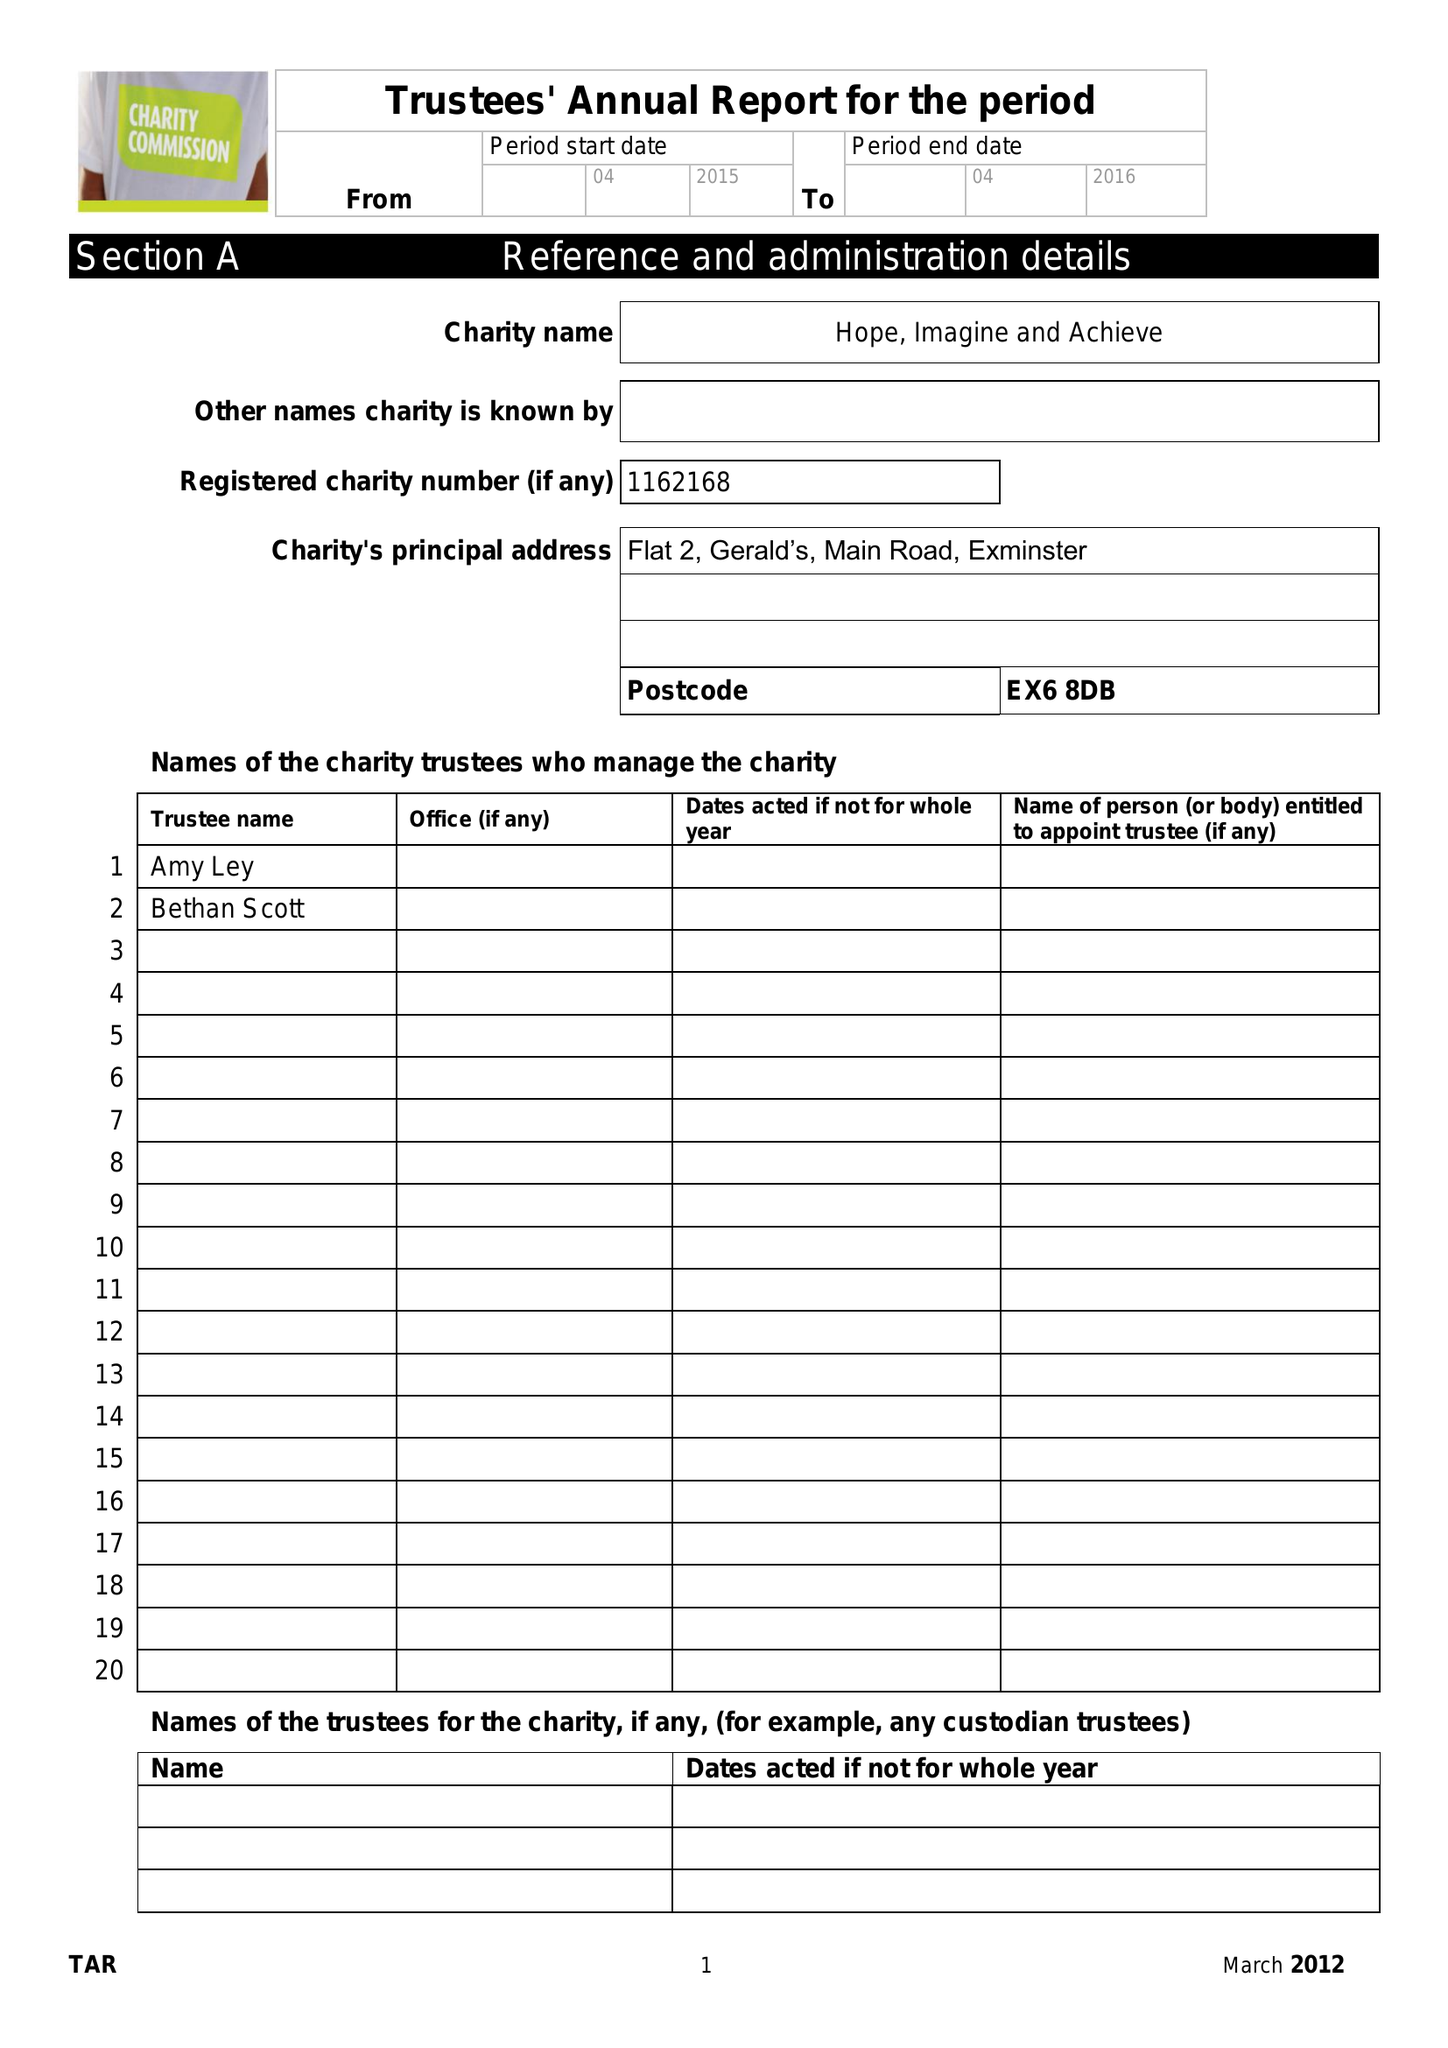What is the value for the report_date?
Answer the question using a single word or phrase. 2016-04-05 